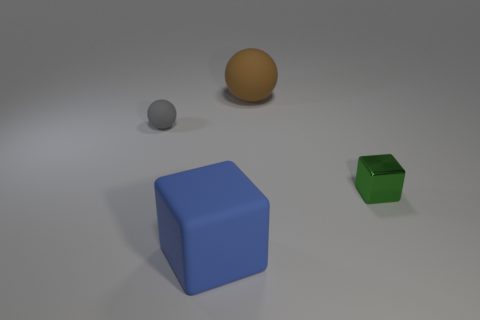What material is the tiny object on the right side of the large rubber thing that is in front of the tiny object in front of the tiny rubber sphere?
Provide a short and direct response. Metal. Are there more things that are right of the big brown sphere than purple things?
Keep it short and to the point. Yes. There is a green cube that is the same size as the gray matte thing; what is its material?
Make the answer very short. Metal. Is there a gray matte thing that has the same size as the green object?
Give a very brief answer. Yes. There is a block that is to the left of the big brown rubber ball; how big is it?
Offer a very short reply. Large. The gray rubber sphere has what size?
Offer a very short reply. Small. How many cubes are either tiny gray metal things or blue things?
Offer a terse response. 1. There is a blue cube that is the same material as the brown ball; what is its size?
Provide a succinct answer. Large. What number of large rubber cubes have the same color as the tiny rubber sphere?
Provide a short and direct response. 0. There is a large rubber ball; are there any large objects left of it?
Your answer should be very brief. Yes. 